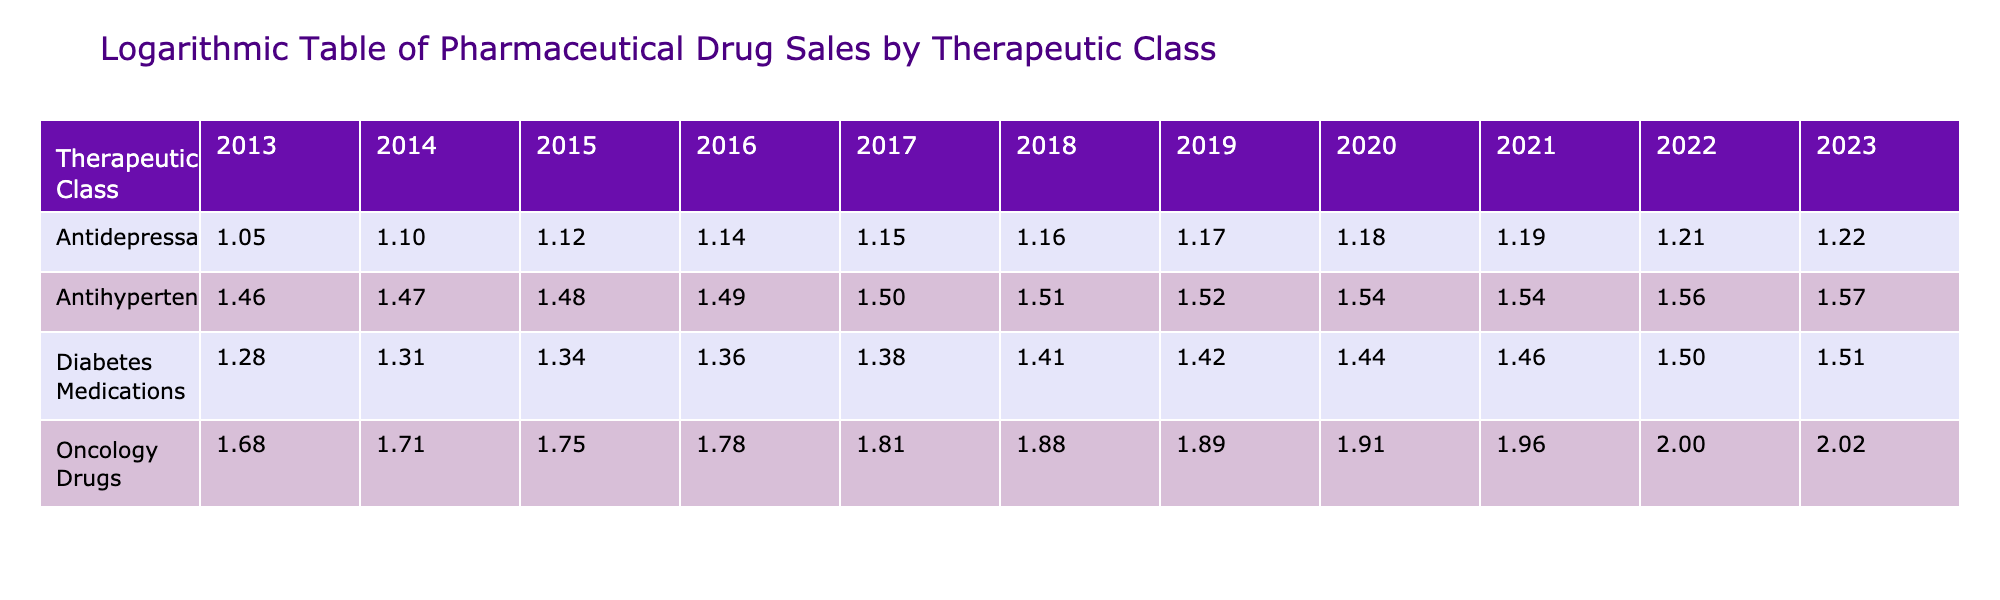What was the total sales for oncology drugs in 2022? For oncology drugs in 2022, the total sales are found in the corresponding row for the year 2022, which indicates a total of 100.3 billion USD.
Answer: 100.3 billion USD What was the total sales for antihypertensives in 2014? The sales for antihypertensives in 2014 are listed directly in the table, showing 29.4 billion USD.
Answer: 29.4 billion USD Which therapeutic class had the highest total sales in 2023? In 2023, assessing all therapeutic classes, oncology drugs have the highest value at 105.7 billion USD.
Answer: Oncology Drugs What was the growth in sales for antidepressants from 2013 to 2023? The sales for antidepressants in 2013 were 11.2 billion USD and in 2023 they reached 16.5 billion USD. The difference is 16.5 - 11.2 = 5.3 billion USD, indicating a growth of 5.3 billion USD over the decade.
Answer: 5.3 billion USD Did diabetes medications consistently increase in sales every year over the last decade? By reviewing the sales figures for diabetes medications from year to year, they show an increase each year from 2013 to 2023, confirming that the sales consistently increased over the decade.
Answer: Yes What is the average total sales of antihypertensives over the last decade? To find the average, first sum the total sales from each year (28.9 + 29.4 + 30.1 + 31.0 + 31.8 + 32.5 + 33.0 + 34.3 + 35.0 + 36.1 + 36.8 =  360.0 billion USD) and then divide by the number of years (11). Thus, the average is 360.0 / 11 = approximately 32.73 billion USD.
Answer: Approximately 32.73 billion USD What was the annual increase in sales for oncology drugs between 2021 and 2022? The sales for oncology drugs in 2021 were 92.0 billion USD, and in 2022, they increased to 100.3 billion USD. To find the annual increase, subtract the earlier year's sales from the later year: 100.3 - 92.0 = 8.3 billion USD.
Answer: 8.3 billion USD How many therapeutic classes exceeded 30 billion USD in sales for at least one year? Scanning through the table, we find that both antihypertensives and oncology drugs exceeded 30 billion USD each year, while diabetes medications crossed 30 billion USD only in 2022 and 2023. Thus, there are three classes that reached or exceeded this threshold.
Answer: Three classes 